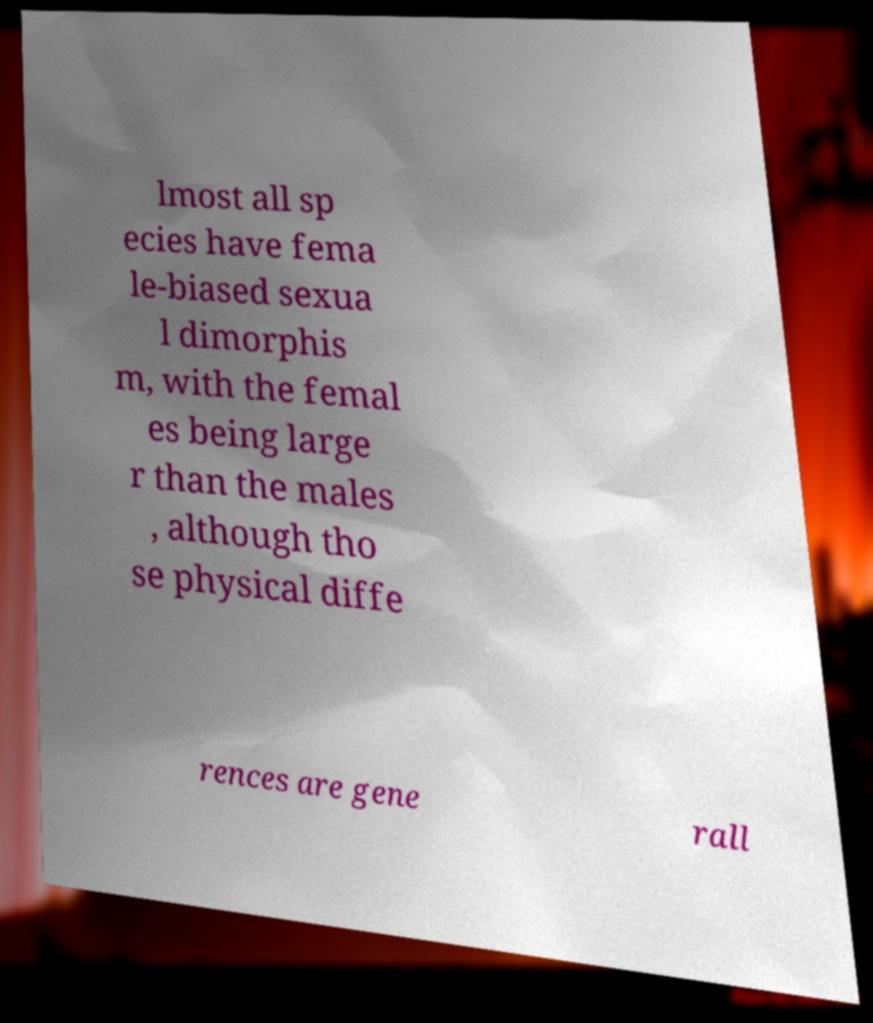Could you extract and type out the text from this image? lmost all sp ecies have fema le-biased sexua l dimorphis m, with the femal es being large r than the males , although tho se physical diffe rences are gene rall 